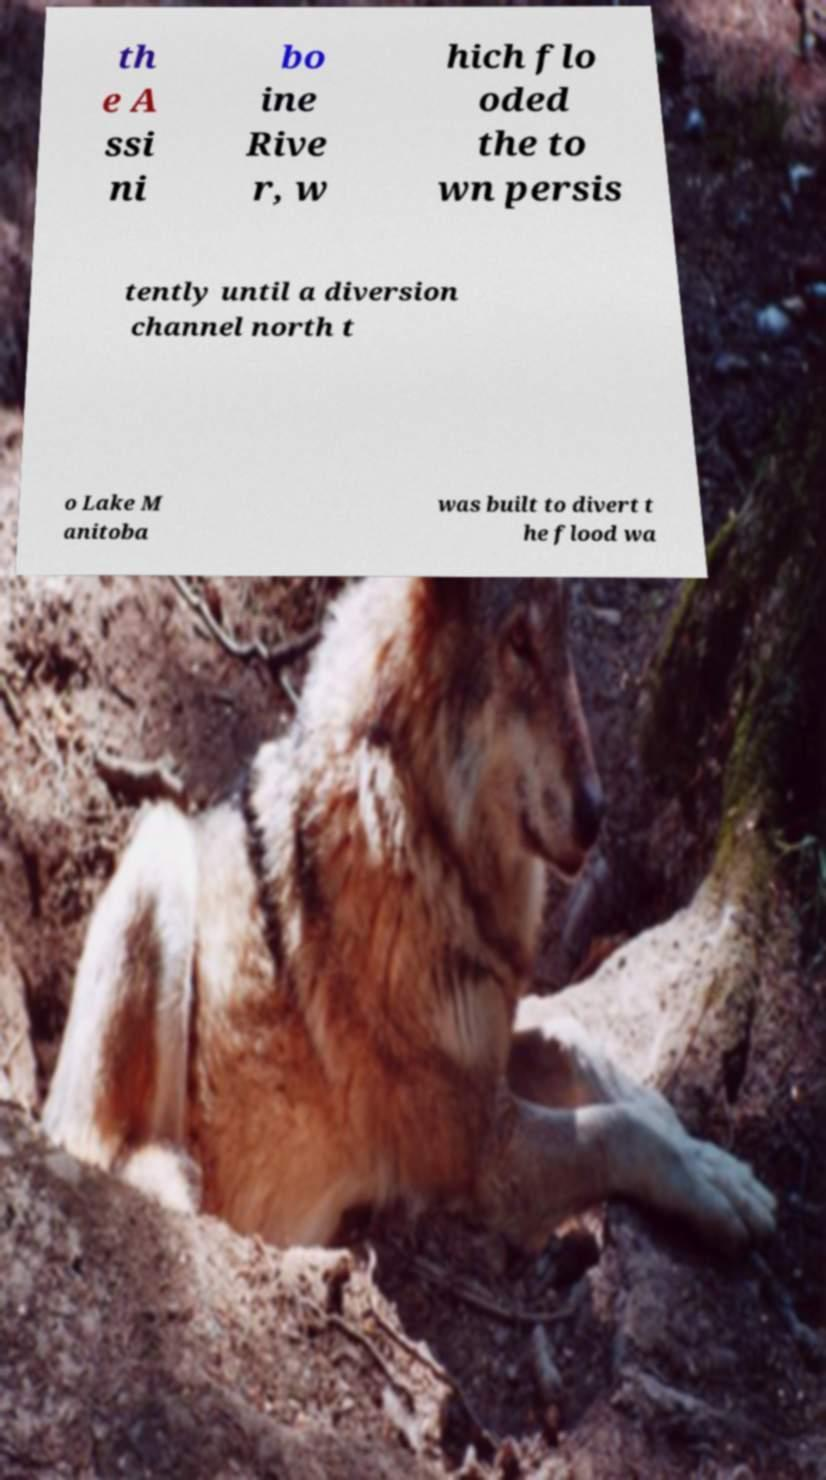Could you assist in decoding the text presented in this image and type it out clearly? th e A ssi ni bo ine Rive r, w hich flo oded the to wn persis tently until a diversion channel north t o Lake M anitoba was built to divert t he flood wa 